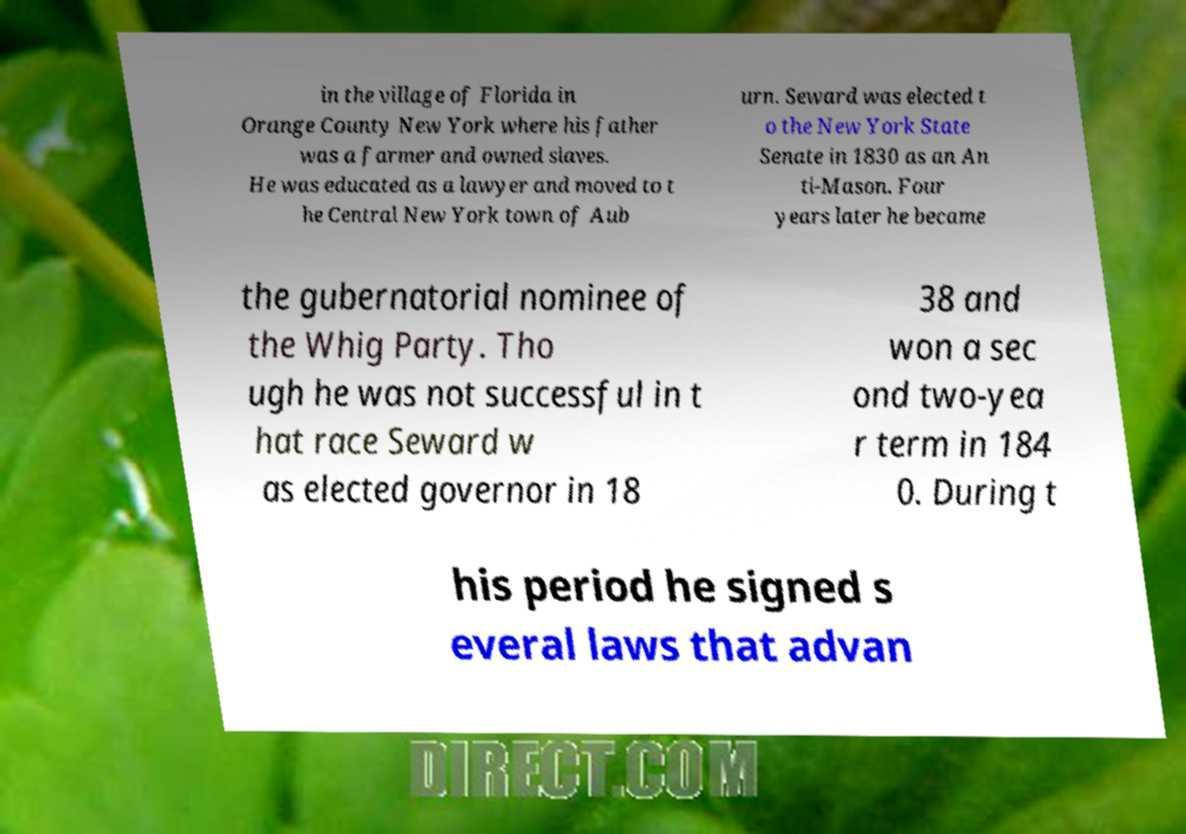What messages or text are displayed in this image? I need them in a readable, typed format. in the village of Florida in Orange County New York where his father was a farmer and owned slaves. He was educated as a lawyer and moved to t he Central New York town of Aub urn. Seward was elected t o the New York State Senate in 1830 as an An ti-Mason. Four years later he became the gubernatorial nominee of the Whig Party. Tho ugh he was not successful in t hat race Seward w as elected governor in 18 38 and won a sec ond two-yea r term in 184 0. During t his period he signed s everal laws that advan 